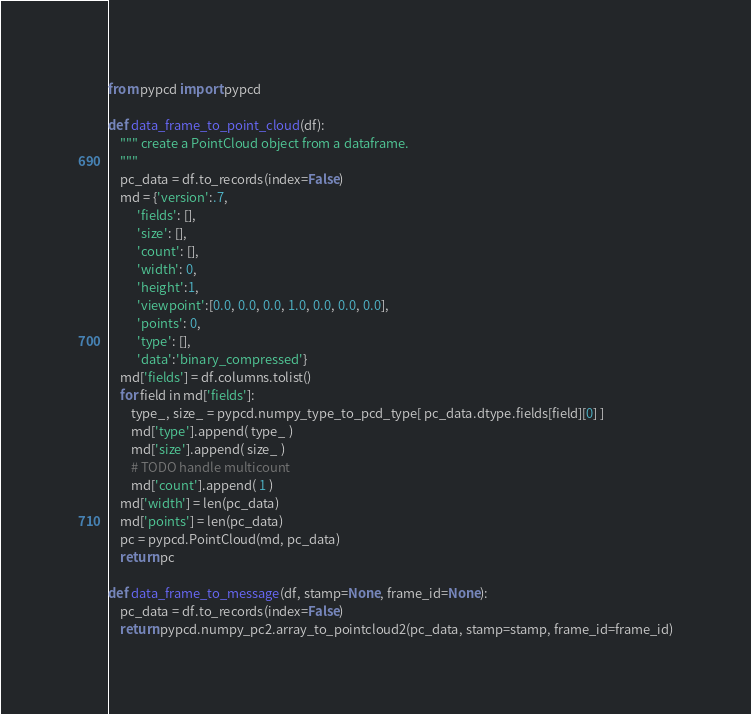<code> <loc_0><loc_0><loc_500><loc_500><_Python_>from pypcd import pypcd

def data_frame_to_point_cloud(df):
    """ create a PointCloud object from a dataframe.
    """
    pc_data = df.to_records(index=False)
    md = {'version':.7,
          'fields': [],
          'size': [],
          'count': [],
          'width': 0,
          'height':1,
          'viewpoint':[0.0, 0.0, 0.0, 1.0, 0.0, 0.0, 0.0],
          'points': 0,
          'type': [],
          'data':'binary_compressed'}
    md['fields'] = df.columns.tolist()
    for field in md['fields']:
        type_, size_ = pypcd.numpy_type_to_pcd_type[ pc_data.dtype.fields[field][0] ]
        md['type'].append( type_ )
        md['size'].append( size_ )
        # TODO handle multicount
        md['count'].append( 1 )
    md['width'] = len(pc_data)
    md['points'] = len(pc_data)
    pc = pypcd.PointCloud(md, pc_data)
    return pc

def data_frame_to_message(df, stamp=None, frame_id=None):
    pc_data = df.to_records(index=False)
    return pypcd.numpy_pc2.array_to_pointcloud2(pc_data, stamp=stamp, frame_id=frame_id)
</code> 